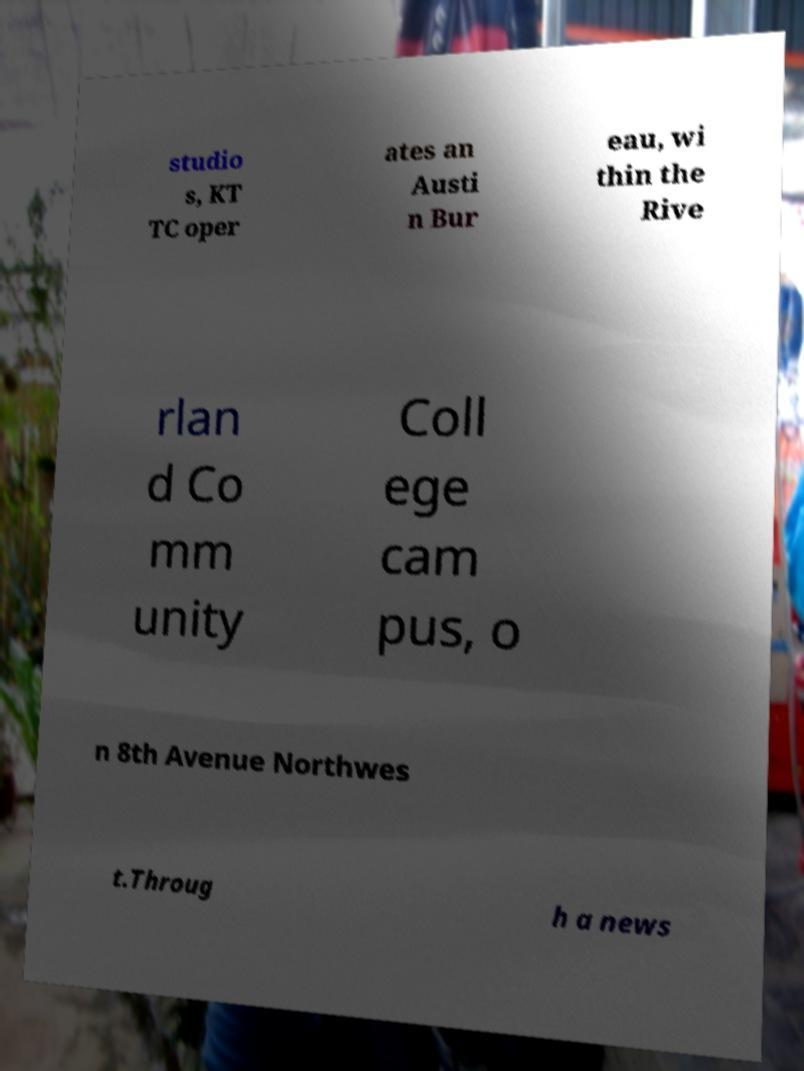Could you assist in decoding the text presented in this image and type it out clearly? studio s, KT TC oper ates an Austi n Bur eau, wi thin the Rive rlan d Co mm unity Coll ege cam pus, o n 8th Avenue Northwes t.Throug h a news 